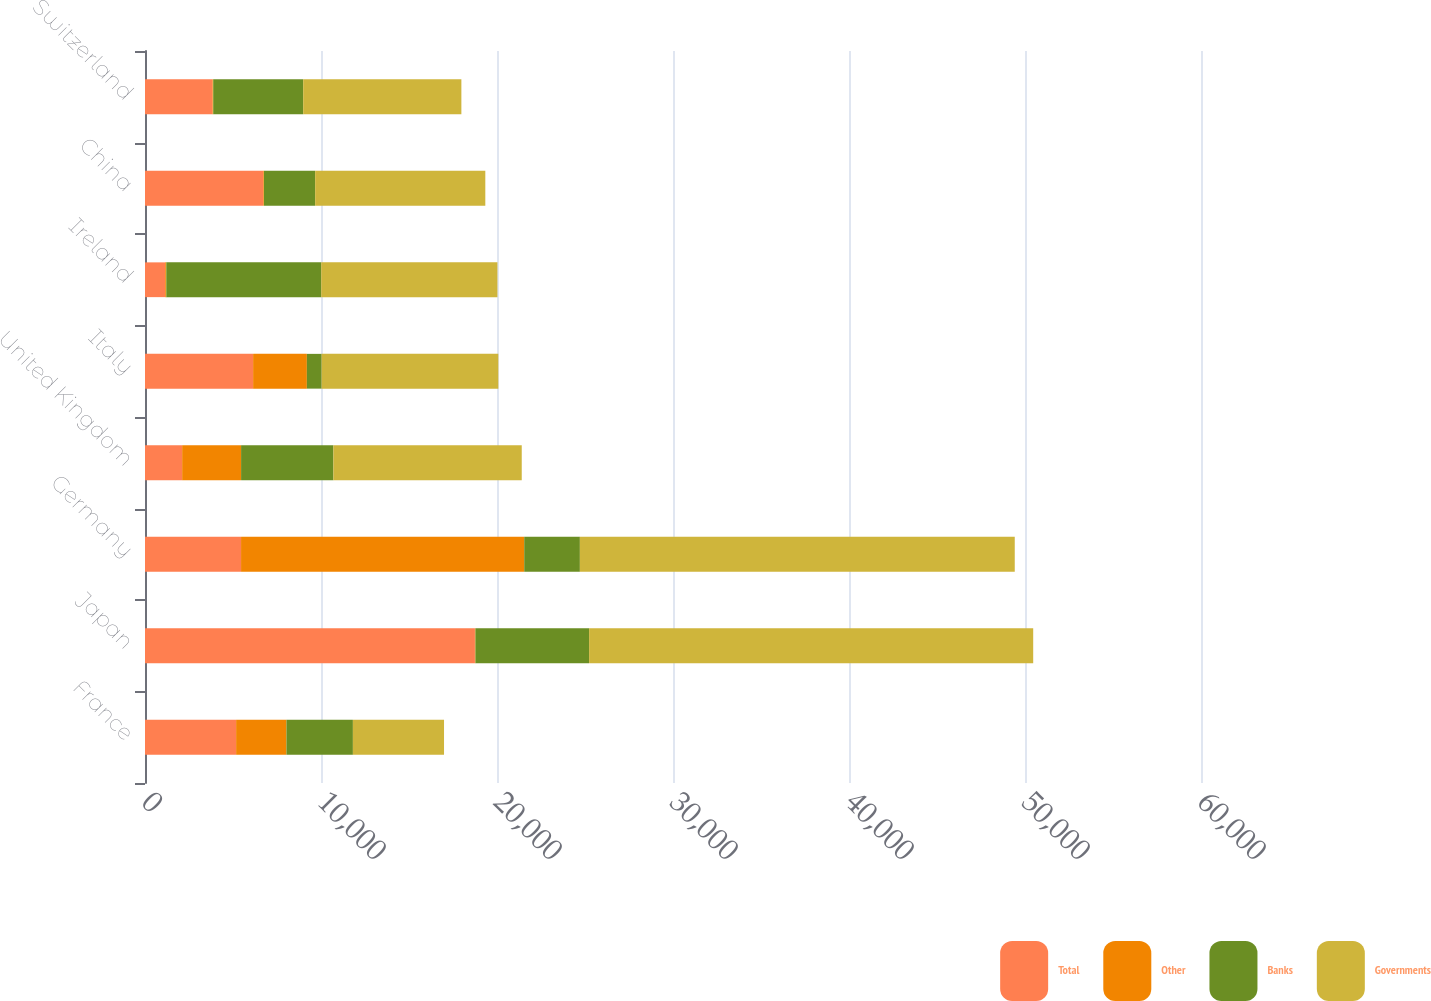Convert chart. <chart><loc_0><loc_0><loc_500><loc_500><stacked_bar_chart><ecel><fcel>France<fcel>Japan<fcel>Germany<fcel>United Kingdom<fcel>Italy<fcel>Ireland<fcel>China<fcel>Switzerland<nl><fcel>Total<fcel>5177.5<fcel>18745<fcel>5458<fcel>2111<fcel>6143<fcel>1148<fcel>6722<fcel>3836<nl><fcel>Other<fcel>2859<fcel>31<fcel>16089<fcel>3349<fcel>3054<fcel>63<fcel>38<fcel>40<nl><fcel>Banks<fcel>3776<fcel>6457<fcel>3162<fcel>5243<fcel>841<fcel>8801<fcel>2908<fcel>5112<nl><fcel>Governments<fcel>5177.5<fcel>25233<fcel>24709<fcel>10703<fcel>10038<fcel>10012<fcel>9668<fcel>8988<nl></chart> 